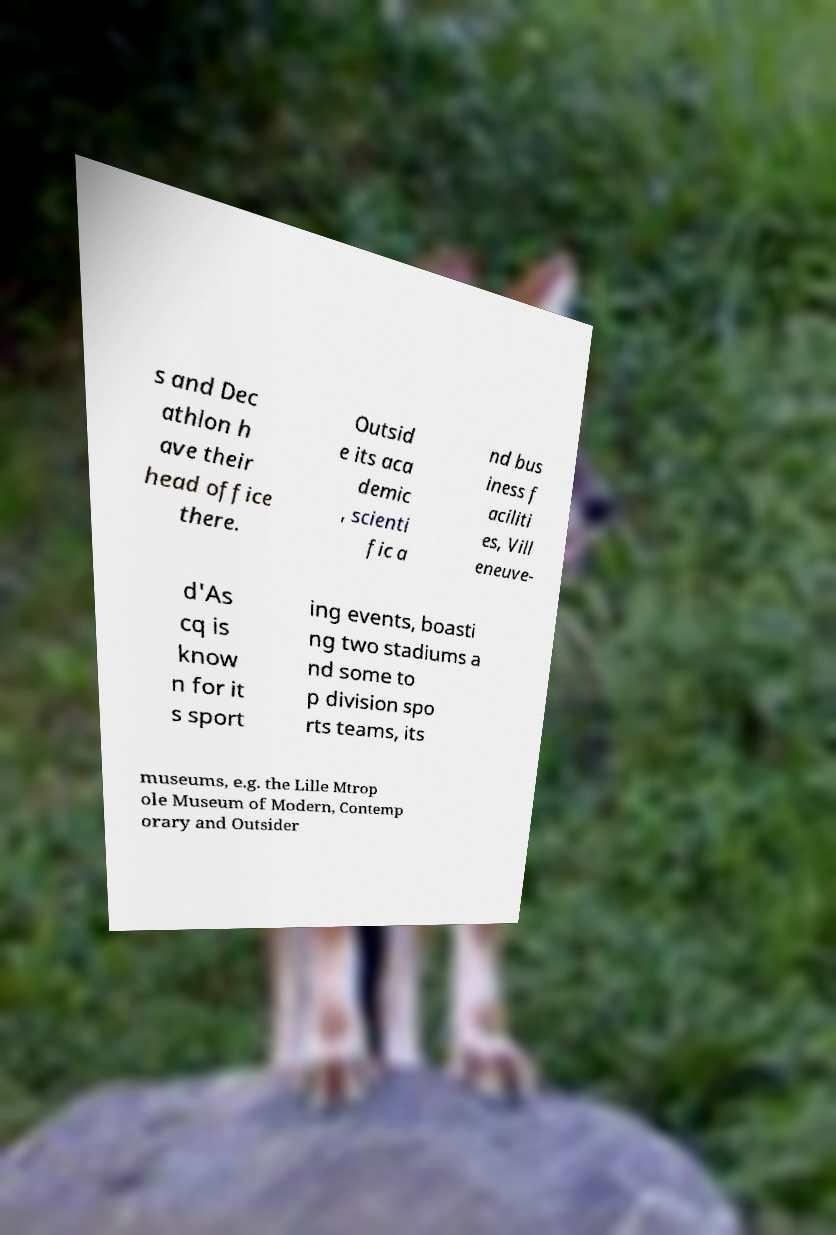For documentation purposes, I need the text within this image transcribed. Could you provide that? s and Dec athlon h ave their head office there. Outsid e its aca demic , scienti fic a nd bus iness f aciliti es, Vill eneuve- d'As cq is know n for it s sport ing events, boasti ng two stadiums a nd some to p division spo rts teams, its museums, e.g. the Lille Mtrop ole Museum of Modern, Contemp orary and Outsider 